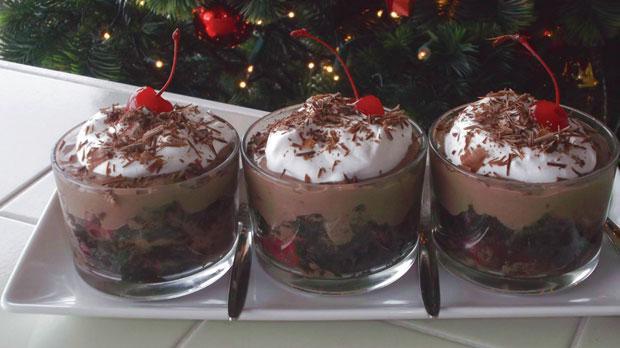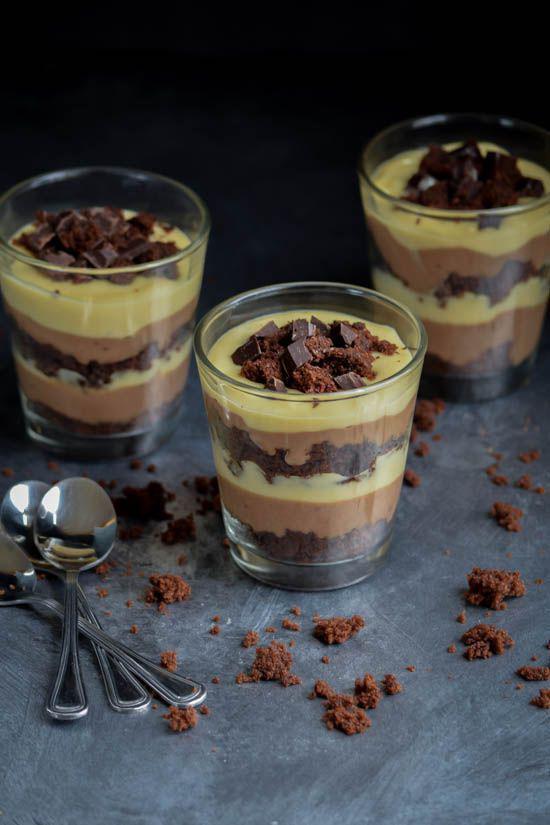The first image is the image on the left, the second image is the image on the right. Examine the images to the left and right. Is the description "One image shows three servings of layered dessert that are not displayed in one horizontal row." accurate? Answer yes or no. Yes. The first image is the image on the left, the second image is the image on the right. Examine the images to the left and right. Is the description "Two large trifle desserts are made in clear bowls with alernating cake and creamy layers, ending with a garnished creamy top." accurate? Answer yes or no. No. 